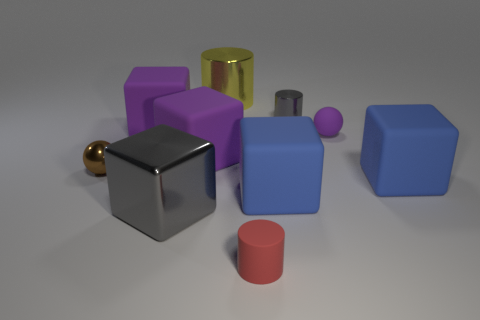What number of other objects are there of the same material as the brown thing?
Give a very brief answer. 3. There is a object that is the same color as the small shiny cylinder; what is its shape?
Your answer should be compact. Cube. What is the size of the metal block that is to the left of the small red matte object?
Provide a short and direct response. Large. There is a brown object that is made of the same material as the large gray block; what shape is it?
Your answer should be compact. Sphere. Do the big yellow cylinder and the gray cylinder that is behind the purple rubber sphere have the same material?
Ensure brevity in your answer.  Yes. Does the small metal thing that is on the left side of the red rubber object have the same shape as the small purple object?
Offer a very short reply. Yes. There is a purple object that is the same shape as the brown object; what is it made of?
Your answer should be compact. Rubber. There is a brown object; is it the same shape as the purple matte thing right of the gray cylinder?
Offer a very short reply. Yes. The thing that is to the right of the red cylinder and behind the tiny purple thing is what color?
Your answer should be compact. Gray. Is there a big blue rubber cylinder?
Keep it short and to the point. No. 